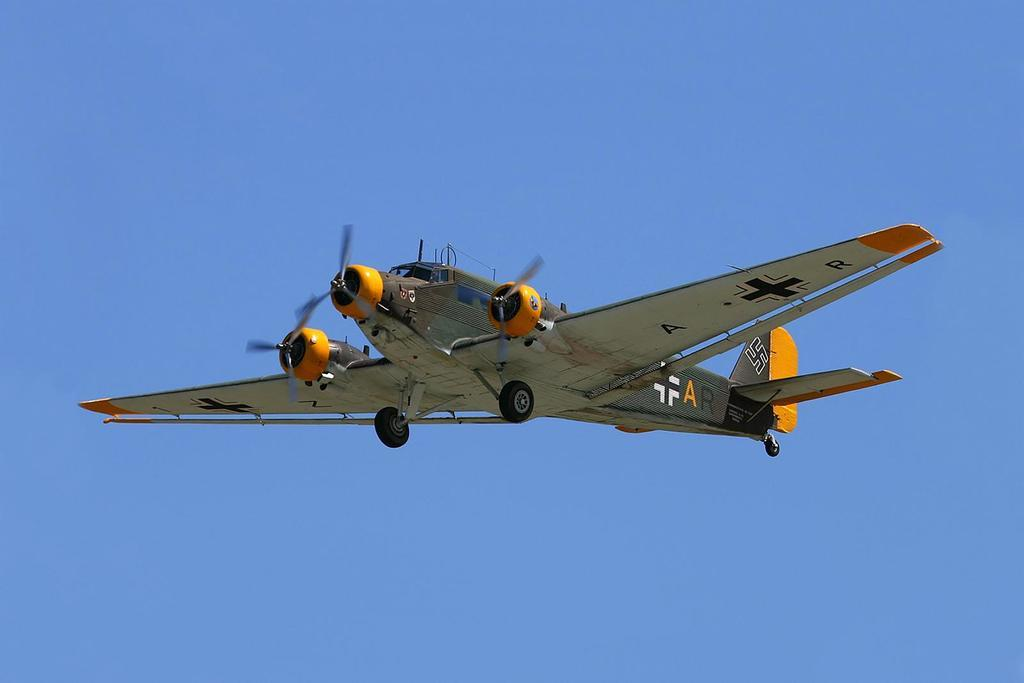What is the main subject of the image? The main subject of the image is an aircraft. Where is the aircraft located in the image? The aircraft is in the air. What can be seen on the aircraft? There is text written on the aircraft. What color is the background of the image? The background of the image is blue. What type of yam is being cooked in the image? There is no yam or cooking activity present in the image; it features an aircraft in the air. What channel is the aircraft tuned to in the image? There is no reference to a channel or television in the image, as it focuses on an aircraft in the air. 